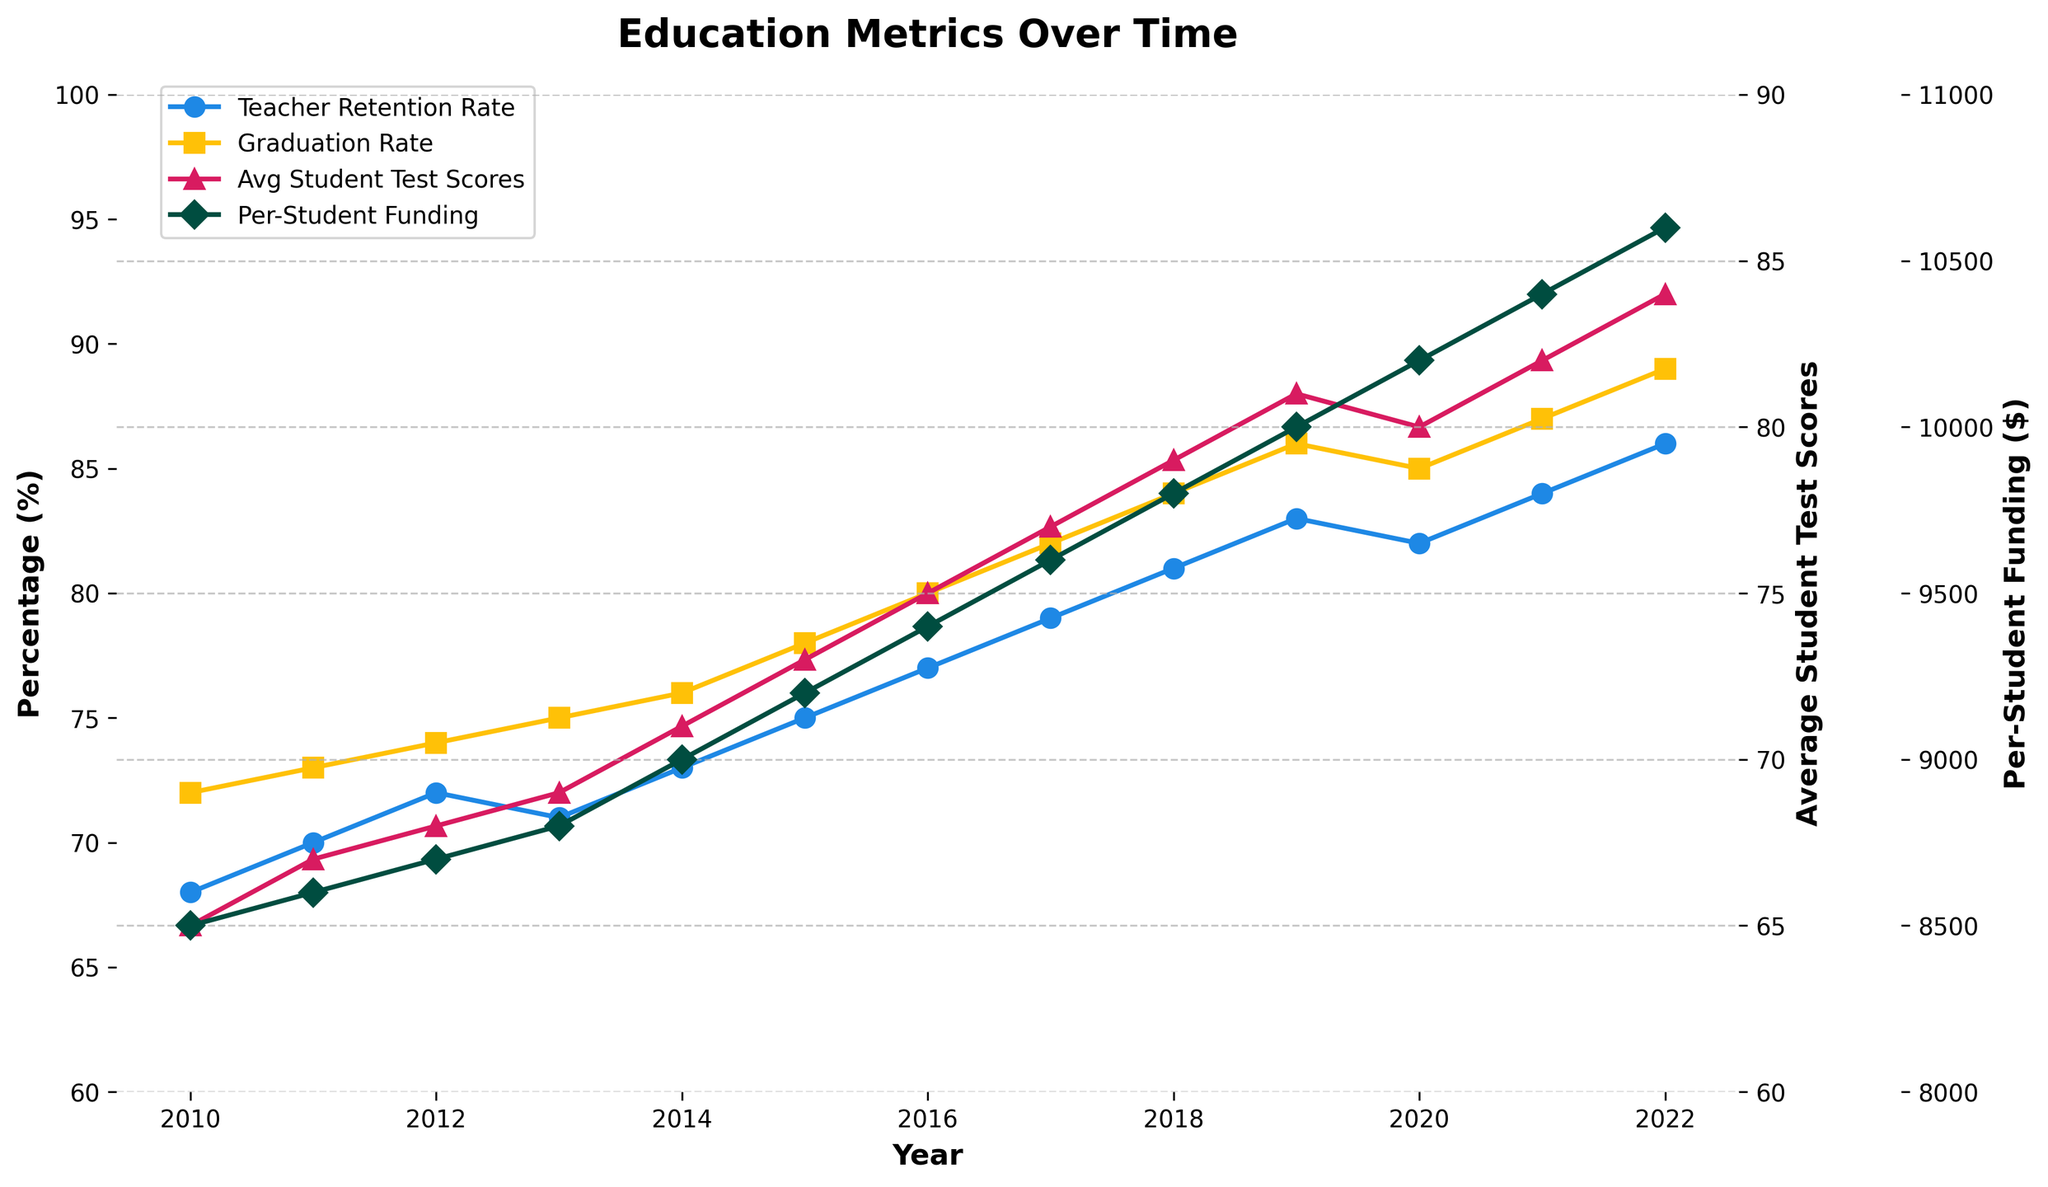What's the trend in teacher retention rate from 2010 to 2022? The teacher retention rate appears to steadily increase from 68% in 2010 to 86% in 2022, with minimal fluctuations over the years.
Answer: Increasing Does the average student test score show any correlation with the teacher retention rate over the years? Both the average student test scores and teacher retention rates increase over the years. This suggests a positive correlation, where higher teacher retention might be associated with higher student test scores.
Answer: Positive correlation How does the graduation rate in 2015 compare to the graduation rate in 2020? In 2015, the graduation rate was 78%. In 2020, the graduation rate was 85%.
Answer: 85% is higher than 78% What is the difference between the per-student funding in 2014 and 2018? In 2014, the per-student funding was $9000, and in 2018 it was $9800. The difference is $9800 - $9000 = $800.
Answer: $800 What visual patterns can be observed concerning the average student test scores and graduation rates over the years? Both the average student test scores (red line with triangle markers) and graduation rates (yellow line with square markers) show an upward trend from 2010 to 2022, suggesting an improvement in student performance metrics.
Answer: Upward trend Which metric had the steepest increase in value over time? The steepest increase can be observed in per-student funding, represented by the green line with diamond markers, rising from $8500 in 2010 to $10600 in 2022.
Answer: Per-student funding In which year did the teacher retention rate first exceed 80%? The teacher retention rate first exceeded 80% in 2018, where it reached 81%.
Answer: 2018 Calculate the average graduation rate from 2010 to 2022. Sum the graduation rates from 2010 to 2022, and divide by the number of years: (72+73+74+75+76+78+80+82+84+85+87+89) / 13 = 81%.
Answer: 81% How do the visual lines for teacher retention rate and per-student funding compare in terms of their slopes? The visual slope for per-student funding (green line) is steeper compared to the teacher retention rate (blue line), indicating a faster increase in funding over the years.
Answer: Per-student funding steeper What is the highest average student test score recorded, and in which year was it achieved? The highest average student test score recorded is 84, achieved in the year 2022.
Answer: 84 in 2022 